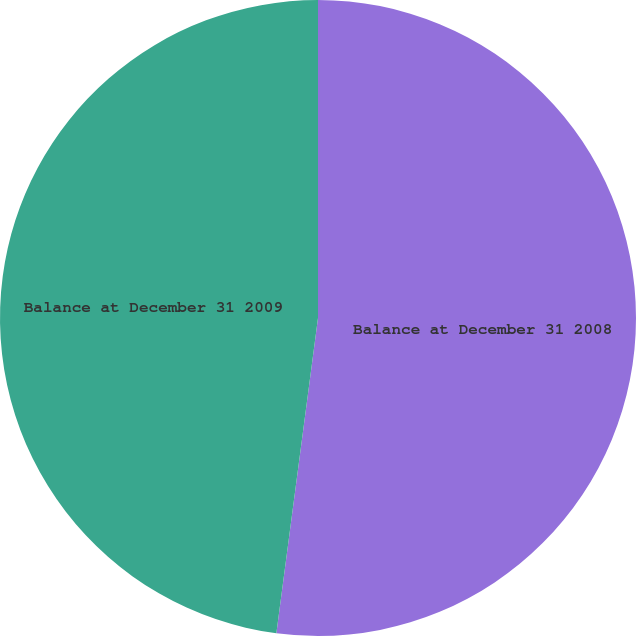Convert chart. <chart><loc_0><loc_0><loc_500><loc_500><pie_chart><fcel>Balance at December 31 2008<fcel>Balance at December 31 2009<nl><fcel>52.09%<fcel>47.91%<nl></chart> 